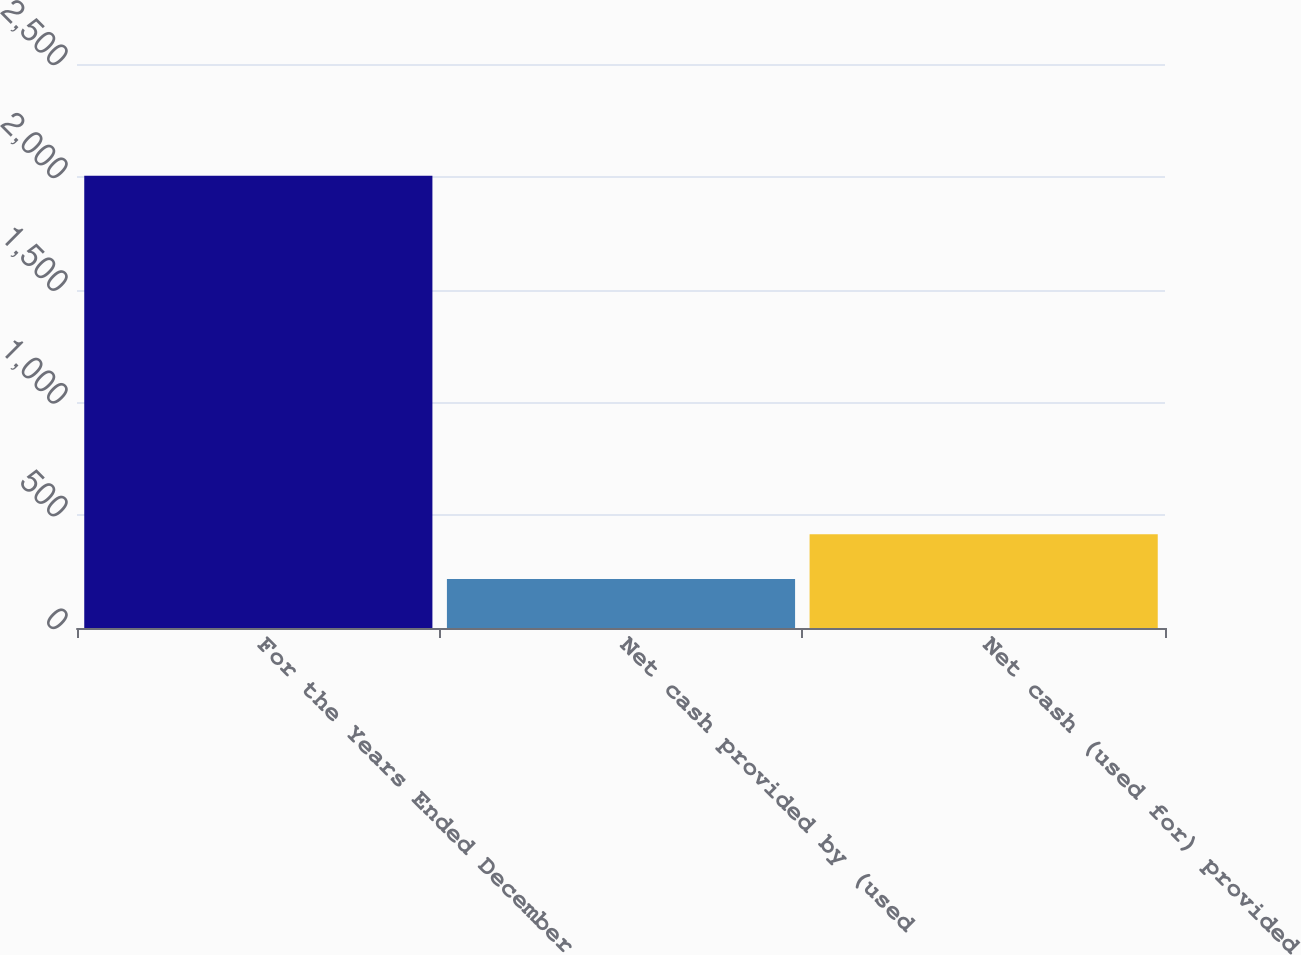<chart> <loc_0><loc_0><loc_500><loc_500><bar_chart><fcel>For the Years Ended December<fcel>Net cash provided by (used<fcel>Net cash (used for) provided<nl><fcel>2005<fcel>216.7<fcel>415.4<nl></chart> 